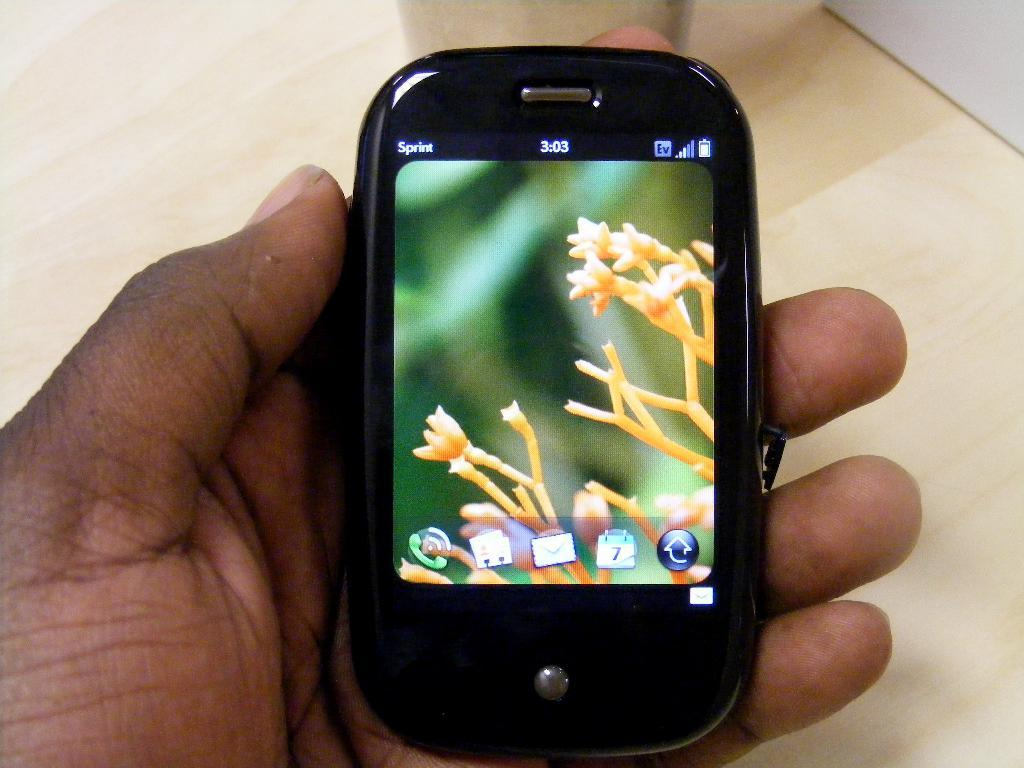What can be seen in the foreground of the image? There is a hand of a person in the foreground of the image. What is the hand holding? The hand is holding a mobile phone. Can you describe any other objects in the image? Yes, there is a wooden object visible in the image. What type of stocking is the writer wearing in the image? There is no writer or stocking present in the image. How deep is the mine visible in the image? There is no mine present in the image. 